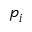Convert formula to latex. <formula><loc_0><loc_0><loc_500><loc_500>p _ { i }</formula> 